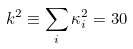<formula> <loc_0><loc_0><loc_500><loc_500>k ^ { 2 } \equiv \sum _ { i } \kappa ^ { 2 } _ { i } = 3 0</formula> 